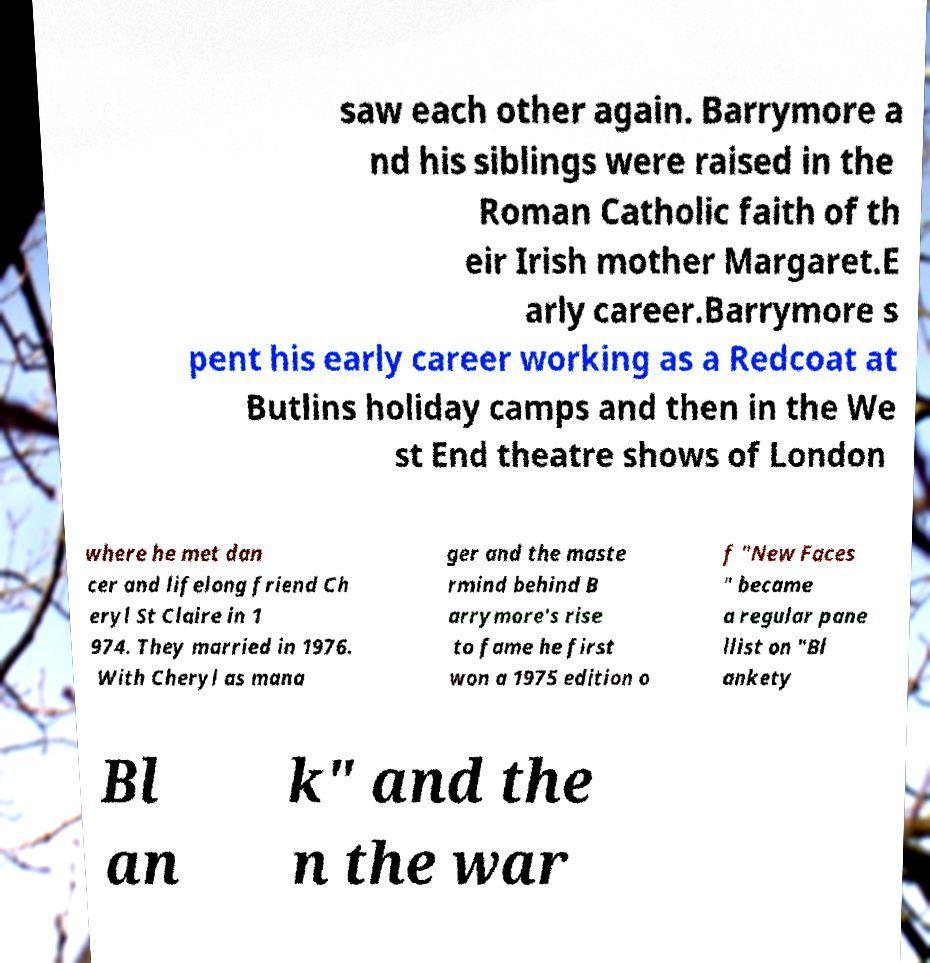There's text embedded in this image that I need extracted. Can you transcribe it verbatim? saw each other again. Barrymore a nd his siblings were raised in the Roman Catholic faith of th eir Irish mother Margaret.E arly career.Barrymore s pent his early career working as a Redcoat at Butlins holiday camps and then in the We st End theatre shows of London where he met dan cer and lifelong friend Ch eryl St Claire in 1 974. They married in 1976. With Cheryl as mana ger and the maste rmind behind B arrymore's rise to fame he first won a 1975 edition o f "New Faces " became a regular pane llist on "Bl ankety Bl an k" and the n the war 